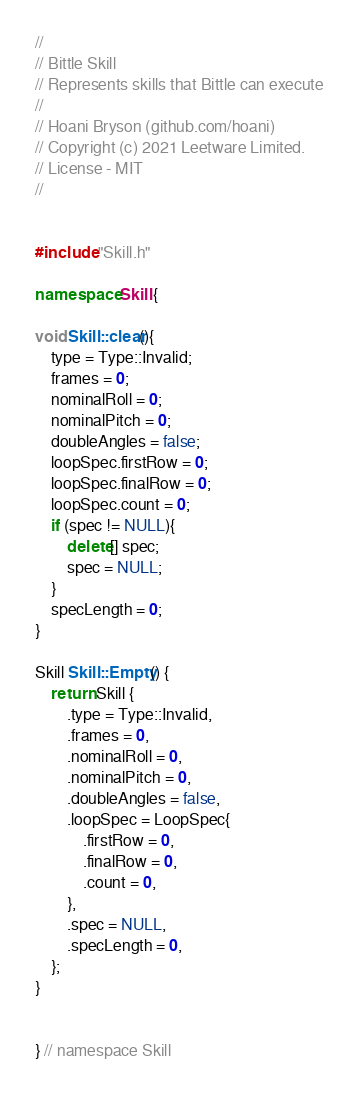<code> <loc_0><loc_0><loc_500><loc_500><_C++_>//
// Bittle Skill
// Represents skills that Bittle can execute
//
// Hoani Bryson (github.com/hoani)
// Copyright (c) 2021 Leetware Limited.
// License - MIT
//


#include "Skill.h"

namespace Skill {

void Skill::clear(){
    type = Type::Invalid;
    frames = 0;
    nominalRoll = 0;
    nominalPitch = 0;
    doubleAngles = false;
    loopSpec.firstRow = 0;
    loopSpec.finalRow = 0;
    loopSpec.count = 0;
    if (spec != NULL){
        delete[] spec;
        spec = NULL;
    }
    specLength = 0; 
}

Skill Skill::Empty() {
    return Skill {
        .type = Type::Invalid,
        .frames = 0,
        .nominalRoll = 0,
        .nominalPitch = 0,
        .doubleAngles = false,
        .loopSpec = LoopSpec{
            .firstRow = 0,
            .finalRow = 0,
            .count = 0,
        },
        .spec = NULL,
        .specLength = 0, 
    };
}


} // namespace Skill</code> 